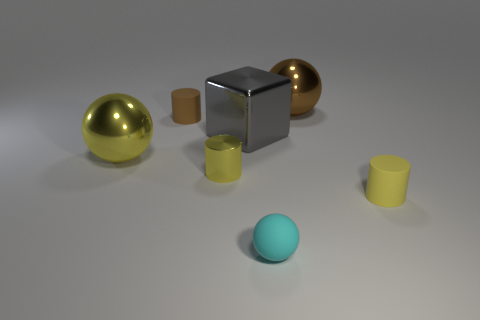What shape is the brown thing on the right side of the small brown rubber thing?
Provide a short and direct response. Sphere. Are there fewer metallic cylinders in front of the matte ball than small metal objects that are on the left side of the tiny metal object?
Provide a short and direct response. No. Are the small yellow thing that is left of the yellow matte cylinder and the large sphere in front of the brown ball made of the same material?
Your response must be concise. Yes. What is the shape of the yellow matte object?
Provide a short and direct response. Cylinder. Are there more tiny metallic things that are to the left of the brown rubber cylinder than balls that are on the left side of the large cube?
Your answer should be compact. No. Does the large shiny object that is to the right of the small cyan thing have the same shape as the big object to the left of the small brown rubber cylinder?
Give a very brief answer. Yes. What number of other things are the same size as the brown matte cylinder?
Keep it short and to the point. 3. What is the size of the cyan matte object?
Give a very brief answer. Small. Is the number of big gray rubber objects the same as the number of small brown rubber cylinders?
Your response must be concise. No. Does the yellow object that is behind the small metallic thing have the same material as the block?
Ensure brevity in your answer.  Yes. 